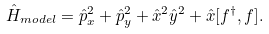<formula> <loc_0><loc_0><loc_500><loc_500>\hat { H } _ { m o d e l } = \hat { p } ^ { 2 } _ { x } + \hat { p } ^ { 2 } _ { y } + \hat { x } ^ { 2 } \hat { y } ^ { 2 } + \hat { x } [ f ^ { \dagger } , f ] .</formula> 